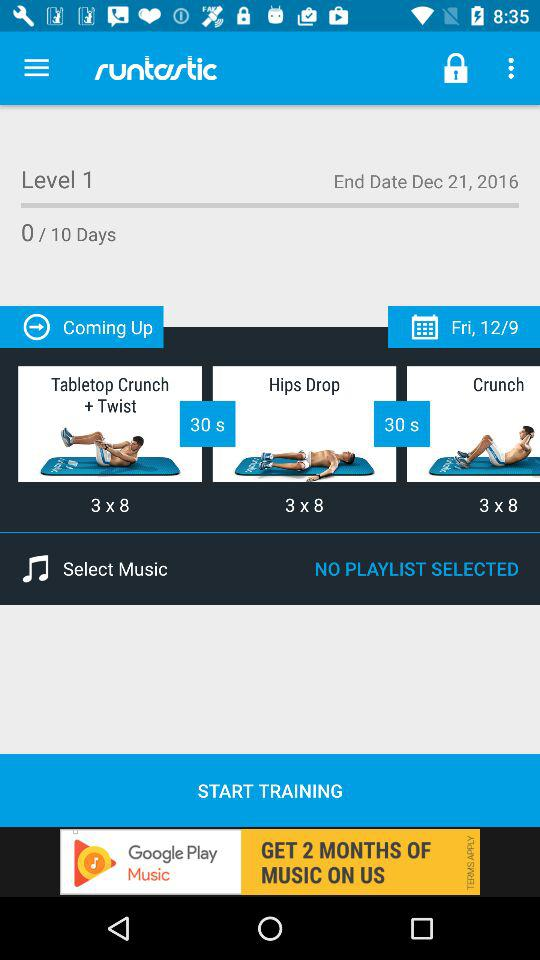What is the upcoming date of training? The upcoming date of training is Friday, December 9. 